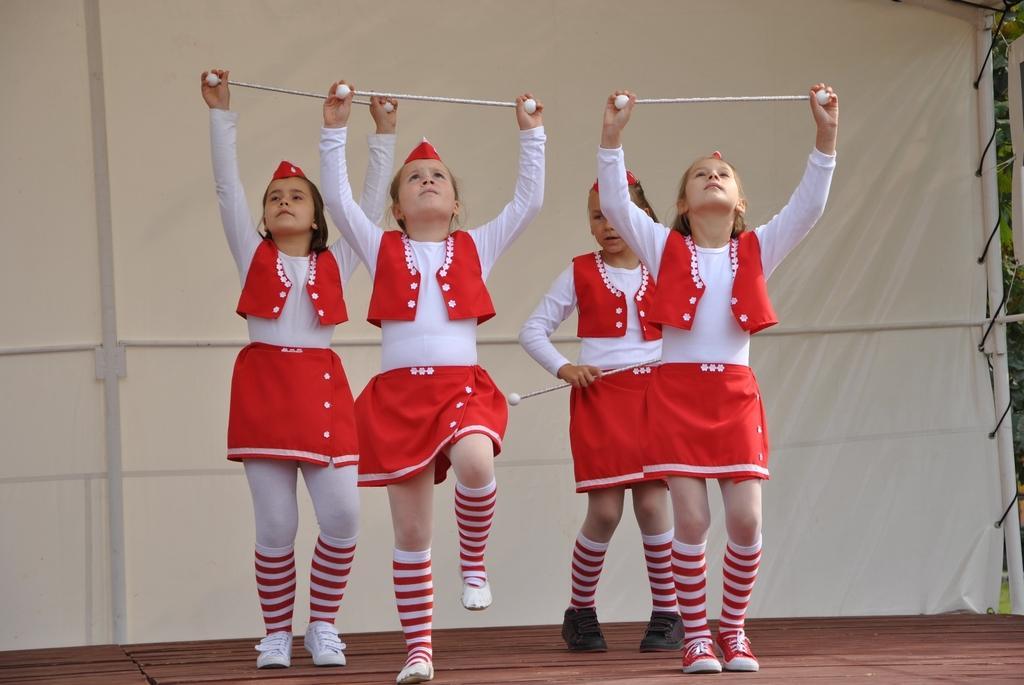In one or two sentences, can you explain what this image depicts? There are four girls wearing cap. They are holding sticks and performing on the stage. In the back there is a white cloth with poles. 